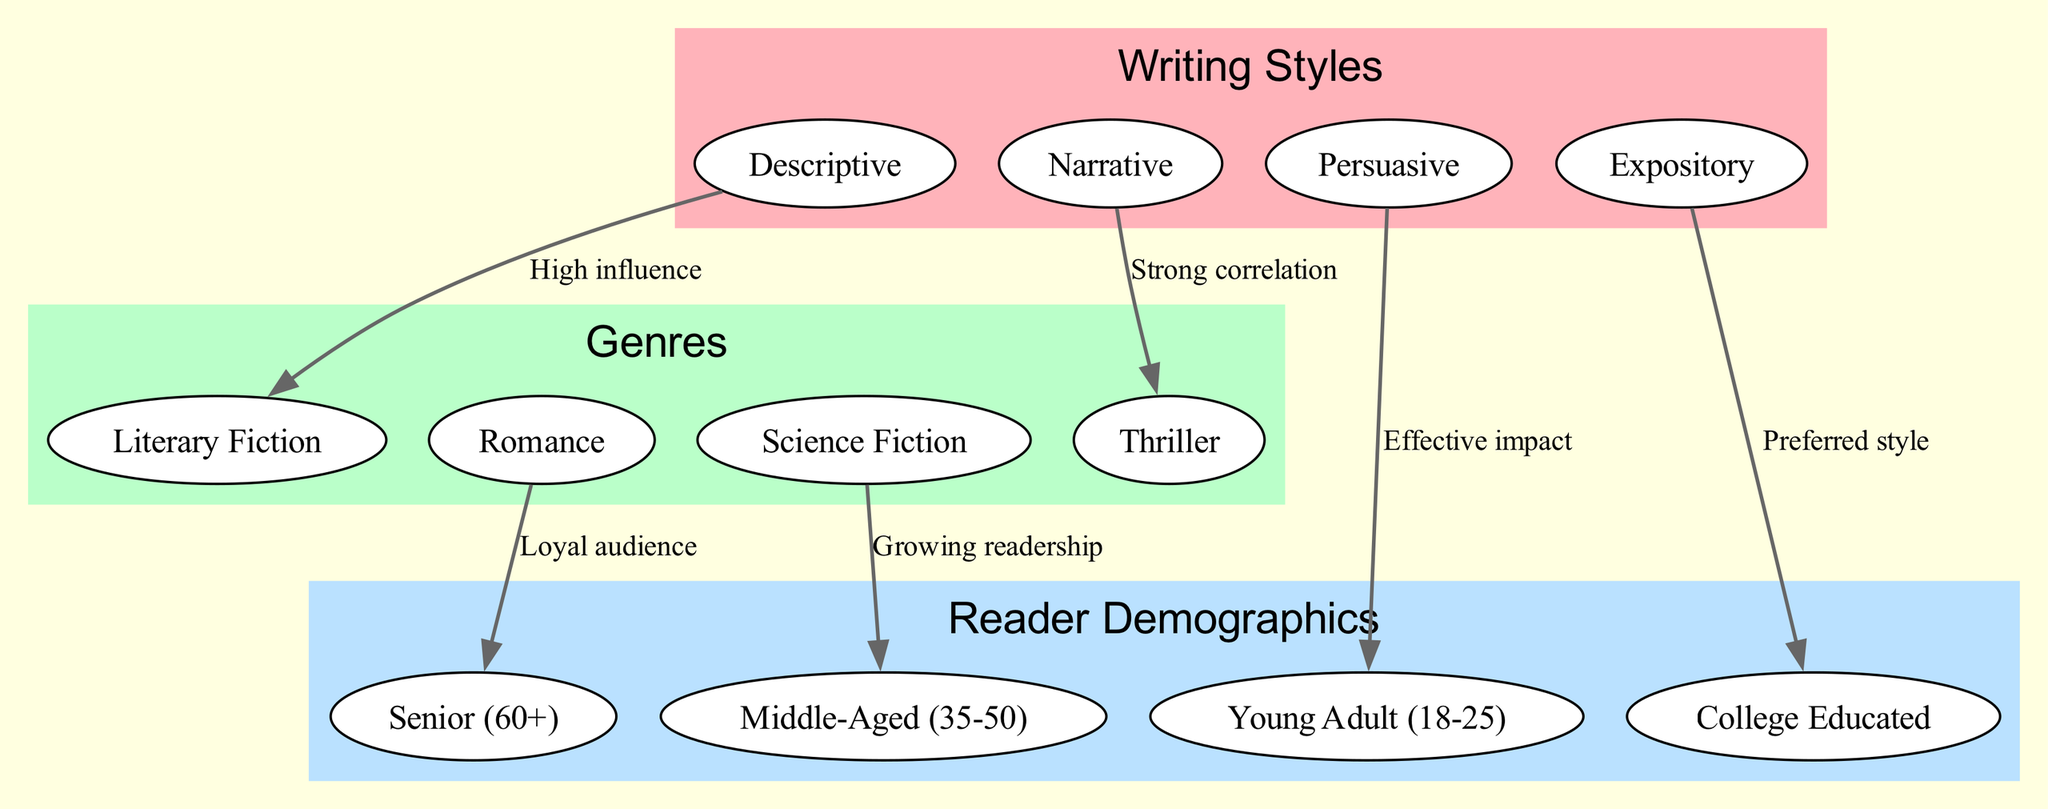What are the writing styles represented in the diagram? The diagram explicitly lists four writing styles as nodes under the 'Writing Styles' section: Descriptive, Narrative, Persuasive, and Expository.
Answer: Descriptive, Narrative, Persuasive, Expository How many genres are depicted in the diagram? The diagram includes a 'Genres' section which contains four distinct genres: Thriller, Romance, Science Fiction, and Literary Fiction. By counting these genres, we find there are four in total.
Answer: 4 Which writing style has a strong correlation with the Thriller genre? By examining the edges in the diagram, the edge labeled "Strong correlation" connects the 'Narrative' writing style to the 'Thriller' genre, indicating this relationship.
Answer: Narrative What demographic is preferred by the Expository writing style? The edge labeled "Preferred style" connects 'Expository' writing style to 'College Educated' under the 'Reader Demographics' section, indicating a preference among this demographic.
Answer: College Educated Which genre has a loyal audience according to the diagram? The edge labeled "Loyal audience" shows that the Romance genre connects with the Senior demographic, indicating that it has a dedicated readership among seniors.
Answer: Romance How many edges are there in the diagram? The diagram lists a total of six edges, each representing a relationship between a writing style and a genre or demographic. Counting all the connections, we find there are six edges.
Answer: 6 Which demographic is most effectively impacted by the Persuasive writing style? The edge labeled "Effective impact" indicates that the 'Persuasive' writing style connects to the 'Young Adult (18-25)' demographic, highlighting its effectiveness with this group.
Answer: Young Adult (18-25) What is the growing readership genre according to the diagram? The edge labeled "Growing readership" links the Science Fiction genre to the Middle-Aged demographic, thus indicating that this genre is becoming increasingly popular among this age group.
Answer: Science Fiction What relationship exists between the Descriptive writing style and the Literary genre? The diagram shows a connection with the label "High influence" between the 'Descriptive' writing style and the 'Literary' genre, suggesting a significant influence of Descriptive writing on this genre.
Answer: High influence 